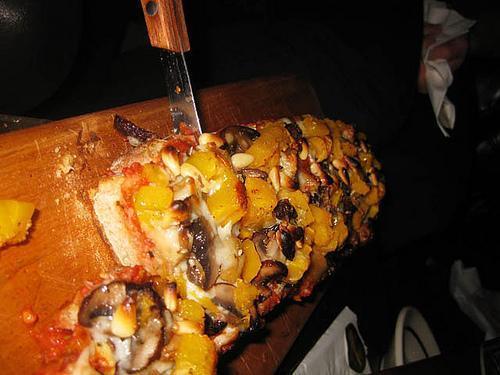Does the image validate the caption "The bowl contains the pizza."?
Answer yes or no. No. 